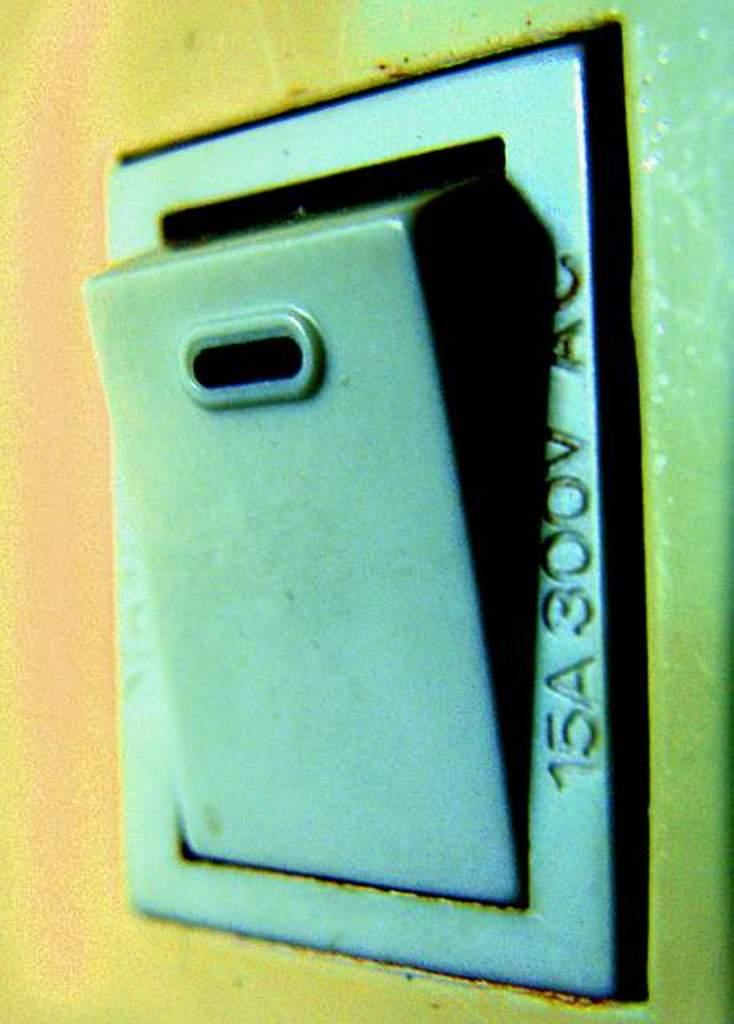Provide a one-sentence caption for the provided image. An outlet box with 15A 300V AC on the side. 